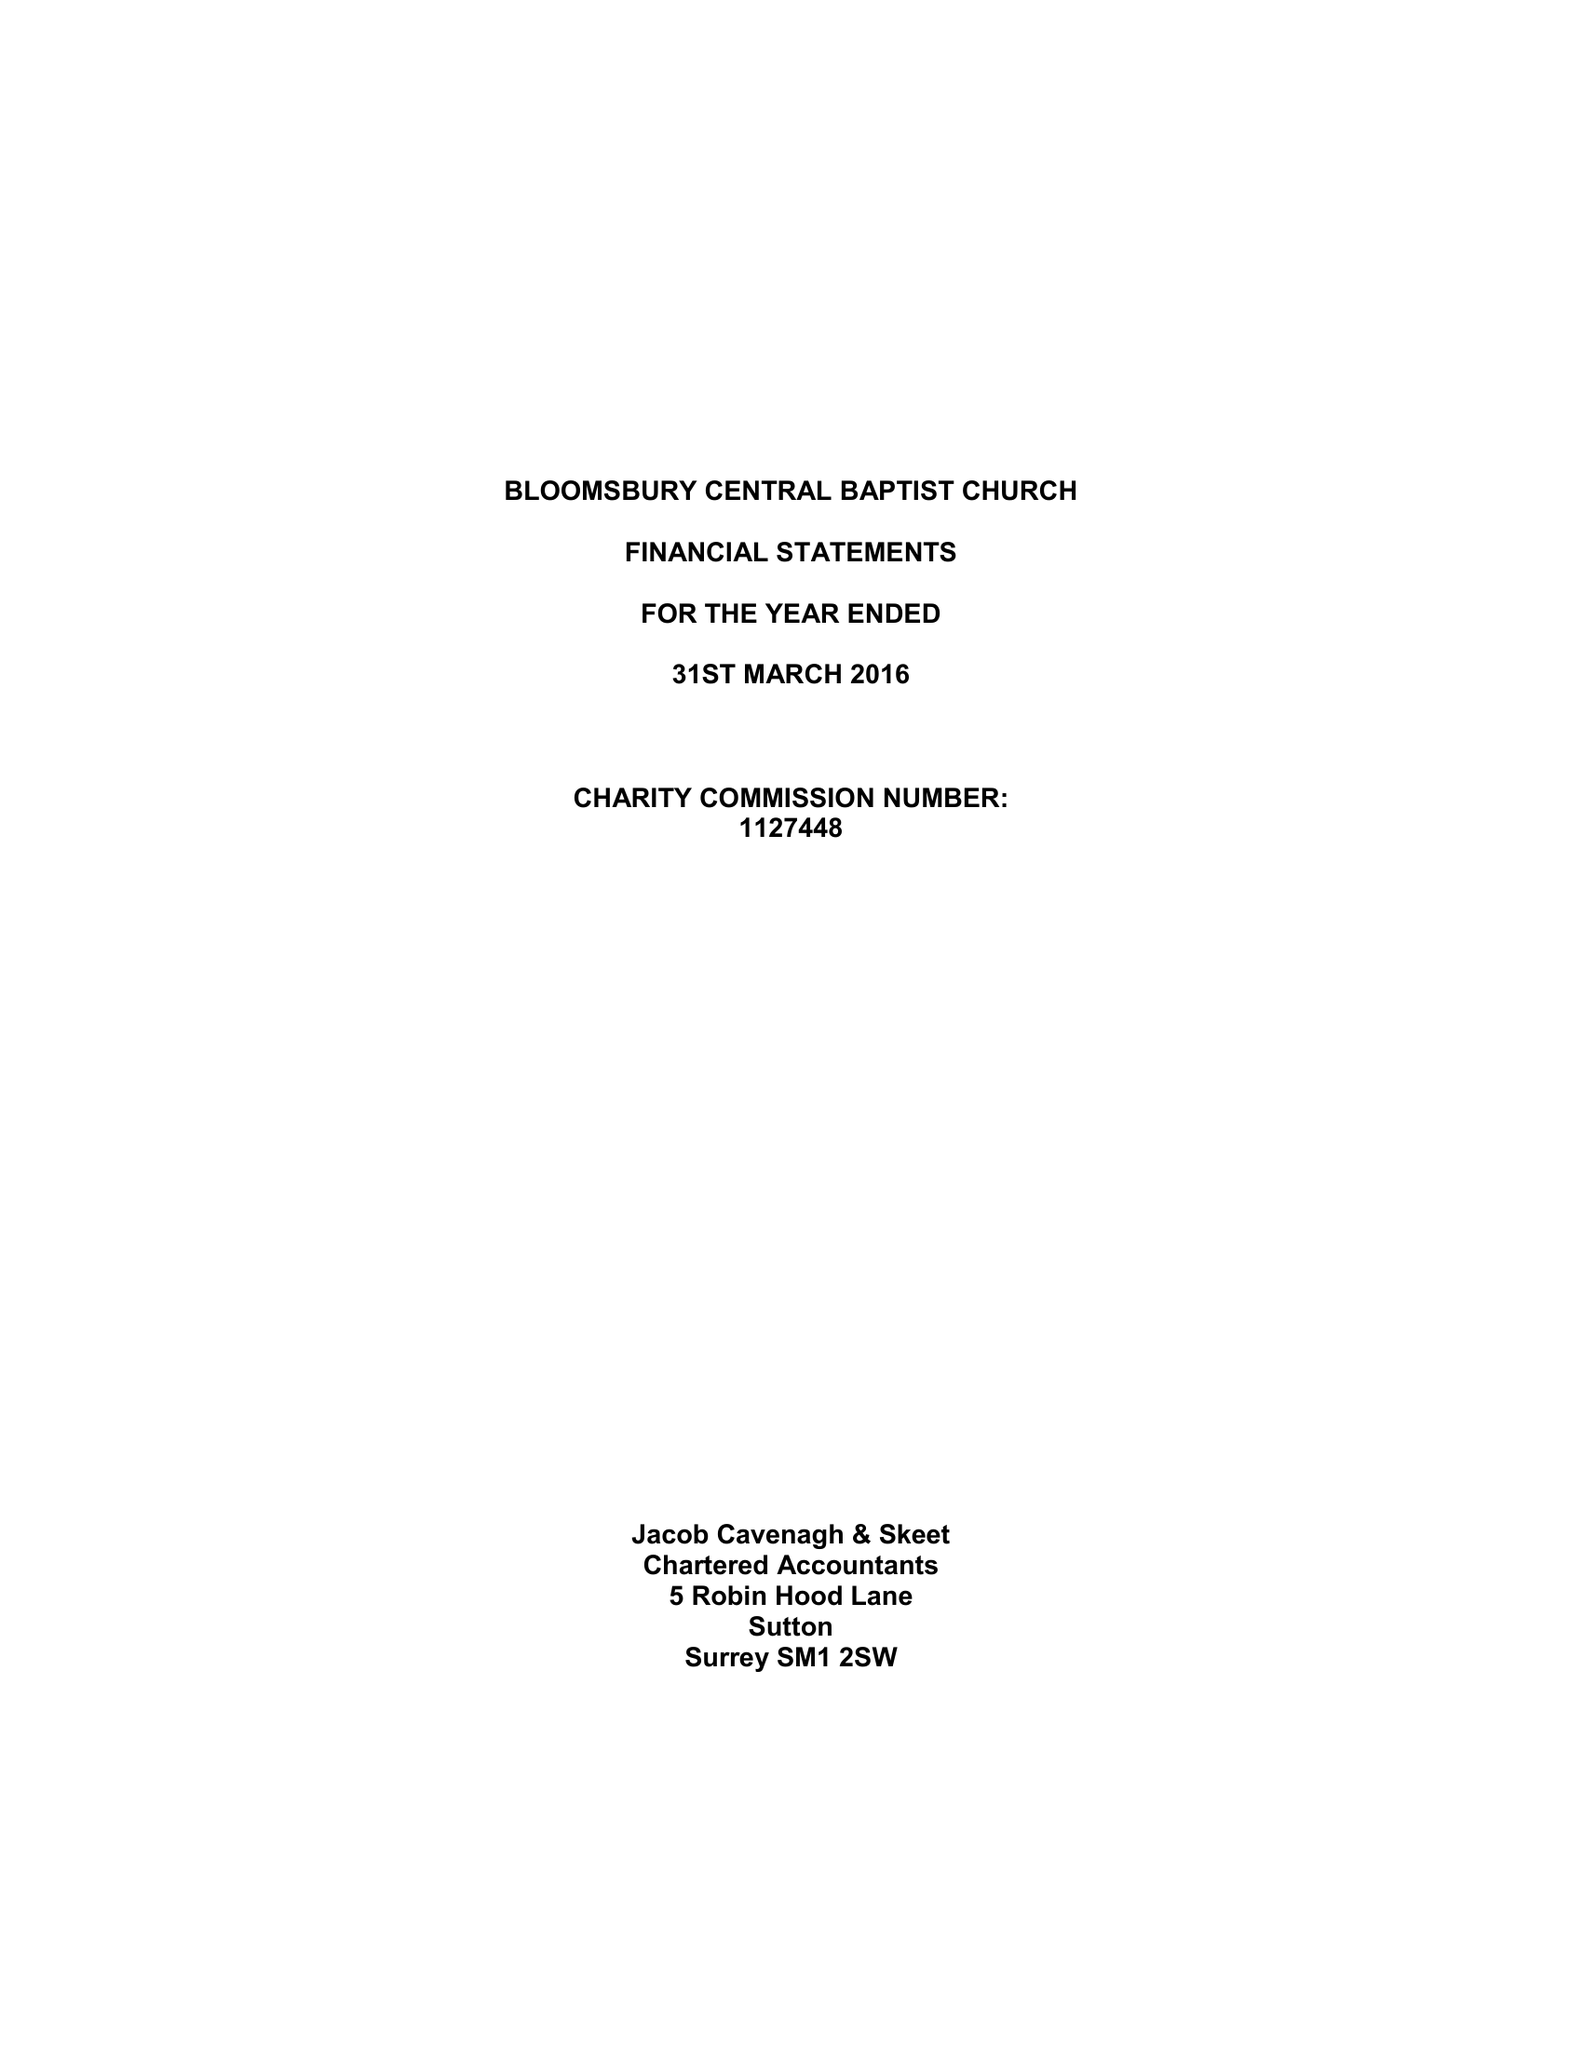What is the value for the charity_number?
Answer the question using a single word or phrase. 1127448 